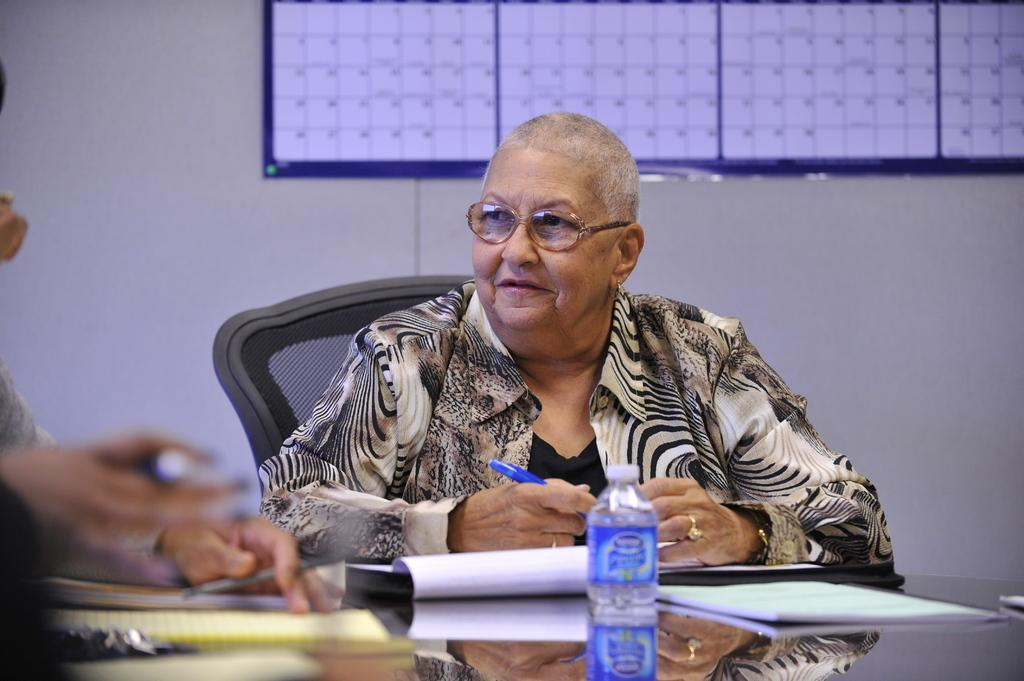What is the color of the wall in the image? The wall in the image is white. What are the people in the image doing? The people in the image are sitting on chairs. What is on the table in the image? There is a table in the image with papers and a bottle on it. Can you see a wren perched on the bottle in the image? There is no wren present in the image. What type of sky is visible in the image? The image does not show the sky; it only shows a white wall, people sitting on chairs, and a table with papers and a bottle on it. 